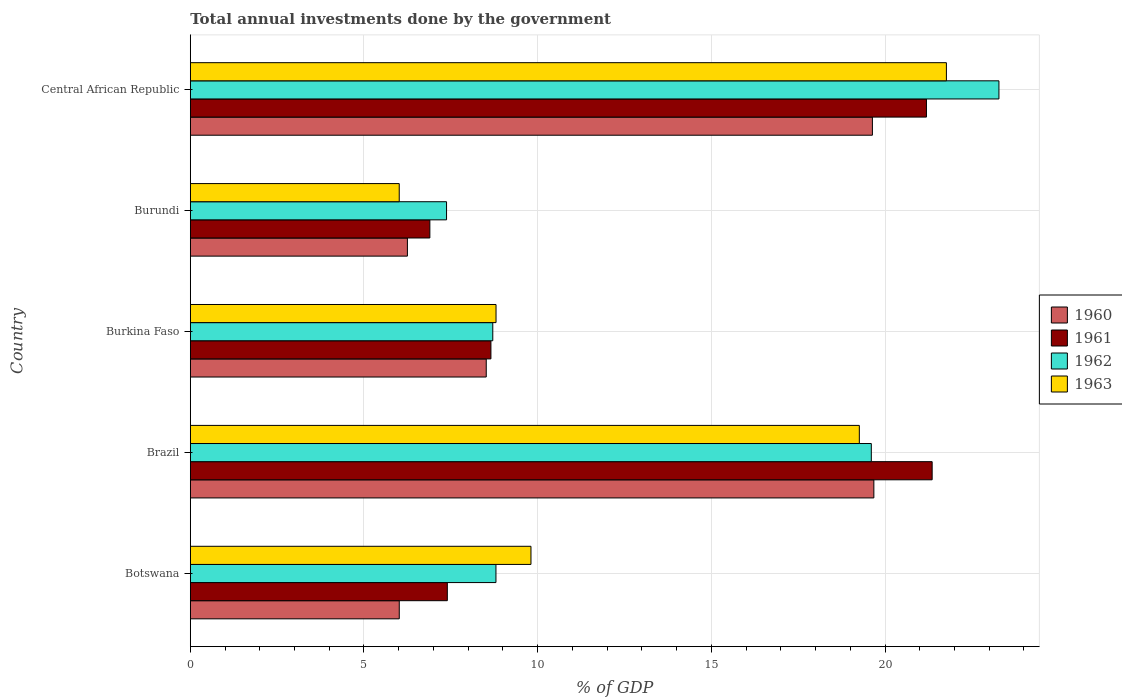How many different coloured bars are there?
Give a very brief answer. 4. How many groups of bars are there?
Your answer should be compact. 5. Are the number of bars per tick equal to the number of legend labels?
Provide a short and direct response. Yes. Are the number of bars on each tick of the Y-axis equal?
Give a very brief answer. Yes. How many bars are there on the 3rd tick from the top?
Provide a succinct answer. 4. How many bars are there on the 1st tick from the bottom?
Your answer should be compact. 4. What is the total annual investments done by the government in 1961 in Brazil?
Provide a short and direct response. 21.36. Across all countries, what is the maximum total annual investments done by the government in 1963?
Ensure brevity in your answer.  21.77. Across all countries, what is the minimum total annual investments done by the government in 1962?
Give a very brief answer. 7.38. In which country was the total annual investments done by the government in 1962 maximum?
Your answer should be very brief. Central African Republic. In which country was the total annual investments done by the government in 1962 minimum?
Your answer should be compact. Burundi. What is the total total annual investments done by the government in 1960 in the graph?
Give a very brief answer. 60.1. What is the difference between the total annual investments done by the government in 1960 in Botswana and that in Burundi?
Keep it short and to the point. -0.23. What is the difference between the total annual investments done by the government in 1960 in Burundi and the total annual investments done by the government in 1961 in Burkina Faso?
Your answer should be very brief. -2.4. What is the average total annual investments done by the government in 1962 per country?
Offer a terse response. 13.55. What is the difference between the total annual investments done by the government in 1961 and total annual investments done by the government in 1963 in Burkina Faso?
Offer a terse response. -0.15. In how many countries, is the total annual investments done by the government in 1960 greater than 1 %?
Your answer should be compact. 5. What is the ratio of the total annual investments done by the government in 1960 in Brazil to that in Central African Republic?
Give a very brief answer. 1. Is the difference between the total annual investments done by the government in 1961 in Botswana and Burundi greater than the difference between the total annual investments done by the government in 1963 in Botswana and Burundi?
Give a very brief answer. No. What is the difference between the highest and the second highest total annual investments done by the government in 1960?
Make the answer very short. 0.04. What is the difference between the highest and the lowest total annual investments done by the government in 1961?
Your answer should be compact. 14.46. In how many countries, is the total annual investments done by the government in 1960 greater than the average total annual investments done by the government in 1960 taken over all countries?
Keep it short and to the point. 2. Is the sum of the total annual investments done by the government in 1961 in Botswana and Brazil greater than the maximum total annual investments done by the government in 1962 across all countries?
Ensure brevity in your answer.  Yes. Is it the case that in every country, the sum of the total annual investments done by the government in 1963 and total annual investments done by the government in 1961 is greater than the sum of total annual investments done by the government in 1962 and total annual investments done by the government in 1960?
Your answer should be compact. No. How many bars are there?
Your answer should be very brief. 20. Are all the bars in the graph horizontal?
Make the answer very short. Yes. How many countries are there in the graph?
Your response must be concise. 5. What is the difference between two consecutive major ticks on the X-axis?
Make the answer very short. 5. Are the values on the major ticks of X-axis written in scientific E-notation?
Offer a terse response. No. How many legend labels are there?
Provide a succinct answer. 4. What is the title of the graph?
Your response must be concise. Total annual investments done by the government. What is the label or title of the X-axis?
Offer a terse response. % of GDP. What is the label or title of the Y-axis?
Your answer should be compact. Country. What is the % of GDP of 1960 in Botswana?
Your answer should be compact. 6.02. What is the % of GDP in 1961 in Botswana?
Ensure brevity in your answer.  7.4. What is the % of GDP of 1962 in Botswana?
Your answer should be compact. 8.8. What is the % of GDP of 1963 in Botswana?
Your answer should be very brief. 9.81. What is the % of GDP of 1960 in Brazil?
Provide a short and direct response. 19.68. What is the % of GDP in 1961 in Brazil?
Your response must be concise. 21.36. What is the % of GDP in 1962 in Brazil?
Keep it short and to the point. 19.6. What is the % of GDP in 1963 in Brazil?
Your answer should be compact. 19.26. What is the % of GDP in 1960 in Burkina Faso?
Your response must be concise. 8.52. What is the % of GDP in 1961 in Burkina Faso?
Your response must be concise. 8.65. What is the % of GDP of 1962 in Burkina Faso?
Ensure brevity in your answer.  8.71. What is the % of GDP of 1963 in Burkina Faso?
Ensure brevity in your answer.  8.8. What is the % of GDP in 1960 in Burundi?
Ensure brevity in your answer.  6.25. What is the % of GDP of 1961 in Burundi?
Give a very brief answer. 6.9. What is the % of GDP in 1962 in Burundi?
Keep it short and to the point. 7.38. What is the % of GDP in 1963 in Burundi?
Keep it short and to the point. 6.02. What is the % of GDP in 1960 in Central African Republic?
Offer a terse response. 19.64. What is the % of GDP in 1961 in Central African Republic?
Offer a terse response. 21.19. What is the % of GDP of 1962 in Central African Republic?
Your answer should be very brief. 23.28. What is the % of GDP of 1963 in Central African Republic?
Your answer should be compact. 21.77. Across all countries, what is the maximum % of GDP of 1960?
Your answer should be compact. 19.68. Across all countries, what is the maximum % of GDP of 1961?
Your response must be concise. 21.36. Across all countries, what is the maximum % of GDP in 1962?
Provide a succinct answer. 23.28. Across all countries, what is the maximum % of GDP in 1963?
Provide a succinct answer. 21.77. Across all countries, what is the minimum % of GDP of 1960?
Provide a succinct answer. 6.02. Across all countries, what is the minimum % of GDP in 1961?
Your answer should be very brief. 6.9. Across all countries, what is the minimum % of GDP in 1962?
Offer a very short reply. 7.38. Across all countries, what is the minimum % of GDP in 1963?
Your answer should be compact. 6.02. What is the total % of GDP in 1960 in the graph?
Give a very brief answer. 60.1. What is the total % of GDP in 1961 in the graph?
Keep it short and to the point. 65.5. What is the total % of GDP of 1962 in the graph?
Offer a very short reply. 67.77. What is the total % of GDP of 1963 in the graph?
Offer a terse response. 65.65. What is the difference between the % of GDP in 1960 in Botswana and that in Brazil?
Ensure brevity in your answer.  -13.66. What is the difference between the % of GDP of 1961 in Botswana and that in Brazil?
Ensure brevity in your answer.  -13.96. What is the difference between the % of GDP of 1962 in Botswana and that in Brazil?
Your answer should be very brief. -10.81. What is the difference between the % of GDP of 1963 in Botswana and that in Brazil?
Provide a short and direct response. -9.45. What is the difference between the % of GDP in 1960 in Botswana and that in Burkina Faso?
Give a very brief answer. -2.5. What is the difference between the % of GDP in 1961 in Botswana and that in Burkina Faso?
Provide a short and direct response. -1.25. What is the difference between the % of GDP of 1962 in Botswana and that in Burkina Faso?
Make the answer very short. 0.09. What is the difference between the % of GDP of 1963 in Botswana and that in Burkina Faso?
Provide a short and direct response. 1.01. What is the difference between the % of GDP in 1960 in Botswana and that in Burundi?
Your response must be concise. -0.23. What is the difference between the % of GDP of 1961 in Botswana and that in Burundi?
Offer a terse response. 0.5. What is the difference between the % of GDP of 1962 in Botswana and that in Burundi?
Give a very brief answer. 1.42. What is the difference between the % of GDP of 1963 in Botswana and that in Burundi?
Offer a terse response. 3.79. What is the difference between the % of GDP in 1960 in Botswana and that in Central African Republic?
Your answer should be compact. -13.62. What is the difference between the % of GDP of 1961 in Botswana and that in Central African Republic?
Your answer should be very brief. -13.79. What is the difference between the % of GDP of 1962 in Botswana and that in Central African Republic?
Give a very brief answer. -14.48. What is the difference between the % of GDP in 1963 in Botswana and that in Central African Republic?
Give a very brief answer. -11.96. What is the difference between the % of GDP in 1960 in Brazil and that in Burkina Faso?
Give a very brief answer. 11.16. What is the difference between the % of GDP in 1961 in Brazil and that in Burkina Faso?
Keep it short and to the point. 12.7. What is the difference between the % of GDP of 1962 in Brazil and that in Burkina Faso?
Provide a short and direct response. 10.9. What is the difference between the % of GDP of 1963 in Brazil and that in Burkina Faso?
Make the answer very short. 10.46. What is the difference between the % of GDP in 1960 in Brazil and that in Burundi?
Provide a short and direct response. 13.43. What is the difference between the % of GDP of 1961 in Brazil and that in Burundi?
Keep it short and to the point. 14.46. What is the difference between the % of GDP in 1962 in Brazil and that in Burundi?
Keep it short and to the point. 12.23. What is the difference between the % of GDP in 1963 in Brazil and that in Burundi?
Offer a very short reply. 13.24. What is the difference between the % of GDP in 1960 in Brazil and that in Central African Republic?
Provide a succinct answer. 0.04. What is the difference between the % of GDP of 1961 in Brazil and that in Central African Republic?
Offer a terse response. 0.16. What is the difference between the % of GDP in 1962 in Brazil and that in Central African Republic?
Provide a short and direct response. -3.67. What is the difference between the % of GDP in 1963 in Brazil and that in Central African Republic?
Offer a very short reply. -2.51. What is the difference between the % of GDP in 1960 in Burkina Faso and that in Burundi?
Your answer should be compact. 2.27. What is the difference between the % of GDP in 1961 in Burkina Faso and that in Burundi?
Ensure brevity in your answer.  1.76. What is the difference between the % of GDP in 1962 in Burkina Faso and that in Burundi?
Provide a succinct answer. 1.33. What is the difference between the % of GDP in 1963 in Burkina Faso and that in Burundi?
Your response must be concise. 2.79. What is the difference between the % of GDP in 1960 in Burkina Faso and that in Central African Republic?
Offer a very short reply. -11.12. What is the difference between the % of GDP in 1961 in Burkina Faso and that in Central African Republic?
Keep it short and to the point. -12.54. What is the difference between the % of GDP in 1962 in Burkina Faso and that in Central African Republic?
Make the answer very short. -14.57. What is the difference between the % of GDP of 1963 in Burkina Faso and that in Central African Republic?
Offer a very short reply. -12.97. What is the difference between the % of GDP in 1960 in Burundi and that in Central African Republic?
Your answer should be very brief. -13.39. What is the difference between the % of GDP in 1961 in Burundi and that in Central African Republic?
Make the answer very short. -14.3. What is the difference between the % of GDP in 1962 in Burundi and that in Central African Republic?
Give a very brief answer. -15.9. What is the difference between the % of GDP of 1963 in Burundi and that in Central African Republic?
Your response must be concise. -15.75. What is the difference between the % of GDP of 1960 in Botswana and the % of GDP of 1961 in Brazil?
Provide a short and direct response. -15.34. What is the difference between the % of GDP in 1960 in Botswana and the % of GDP in 1962 in Brazil?
Provide a succinct answer. -13.59. What is the difference between the % of GDP in 1960 in Botswana and the % of GDP in 1963 in Brazil?
Offer a very short reply. -13.24. What is the difference between the % of GDP of 1961 in Botswana and the % of GDP of 1962 in Brazil?
Give a very brief answer. -12.21. What is the difference between the % of GDP in 1961 in Botswana and the % of GDP in 1963 in Brazil?
Provide a succinct answer. -11.86. What is the difference between the % of GDP of 1962 in Botswana and the % of GDP of 1963 in Brazil?
Keep it short and to the point. -10.46. What is the difference between the % of GDP in 1960 in Botswana and the % of GDP in 1961 in Burkina Faso?
Your answer should be very brief. -2.64. What is the difference between the % of GDP of 1960 in Botswana and the % of GDP of 1962 in Burkina Faso?
Provide a short and direct response. -2.69. What is the difference between the % of GDP in 1960 in Botswana and the % of GDP in 1963 in Burkina Faso?
Ensure brevity in your answer.  -2.79. What is the difference between the % of GDP of 1961 in Botswana and the % of GDP of 1962 in Burkina Faso?
Your answer should be compact. -1.31. What is the difference between the % of GDP in 1961 in Botswana and the % of GDP in 1963 in Burkina Faso?
Your response must be concise. -1.4. What is the difference between the % of GDP in 1962 in Botswana and the % of GDP in 1963 in Burkina Faso?
Offer a terse response. -0. What is the difference between the % of GDP in 1960 in Botswana and the % of GDP in 1961 in Burundi?
Your answer should be compact. -0.88. What is the difference between the % of GDP in 1960 in Botswana and the % of GDP in 1962 in Burundi?
Provide a short and direct response. -1.36. What is the difference between the % of GDP in 1960 in Botswana and the % of GDP in 1963 in Burundi?
Offer a very short reply. 0. What is the difference between the % of GDP of 1961 in Botswana and the % of GDP of 1962 in Burundi?
Ensure brevity in your answer.  0.02. What is the difference between the % of GDP of 1961 in Botswana and the % of GDP of 1963 in Burundi?
Your response must be concise. 1.38. What is the difference between the % of GDP of 1962 in Botswana and the % of GDP of 1963 in Burundi?
Offer a very short reply. 2.78. What is the difference between the % of GDP in 1960 in Botswana and the % of GDP in 1961 in Central African Republic?
Keep it short and to the point. -15.18. What is the difference between the % of GDP of 1960 in Botswana and the % of GDP of 1962 in Central African Republic?
Your response must be concise. -17.26. What is the difference between the % of GDP in 1960 in Botswana and the % of GDP in 1963 in Central African Republic?
Offer a terse response. -15.75. What is the difference between the % of GDP of 1961 in Botswana and the % of GDP of 1962 in Central African Republic?
Provide a succinct answer. -15.88. What is the difference between the % of GDP of 1961 in Botswana and the % of GDP of 1963 in Central African Republic?
Your answer should be compact. -14.37. What is the difference between the % of GDP of 1962 in Botswana and the % of GDP of 1963 in Central African Republic?
Make the answer very short. -12.97. What is the difference between the % of GDP of 1960 in Brazil and the % of GDP of 1961 in Burkina Faso?
Make the answer very short. 11.02. What is the difference between the % of GDP in 1960 in Brazil and the % of GDP in 1962 in Burkina Faso?
Provide a short and direct response. 10.97. What is the difference between the % of GDP in 1960 in Brazil and the % of GDP in 1963 in Burkina Faso?
Your response must be concise. 10.88. What is the difference between the % of GDP of 1961 in Brazil and the % of GDP of 1962 in Burkina Faso?
Give a very brief answer. 12.65. What is the difference between the % of GDP in 1961 in Brazil and the % of GDP in 1963 in Burkina Faso?
Provide a succinct answer. 12.55. What is the difference between the % of GDP of 1962 in Brazil and the % of GDP of 1963 in Burkina Faso?
Your response must be concise. 10.8. What is the difference between the % of GDP of 1960 in Brazil and the % of GDP of 1961 in Burundi?
Ensure brevity in your answer.  12.78. What is the difference between the % of GDP in 1960 in Brazil and the % of GDP in 1962 in Burundi?
Keep it short and to the point. 12.3. What is the difference between the % of GDP in 1960 in Brazil and the % of GDP in 1963 in Burundi?
Offer a very short reply. 13.66. What is the difference between the % of GDP of 1961 in Brazil and the % of GDP of 1962 in Burundi?
Your response must be concise. 13.98. What is the difference between the % of GDP in 1961 in Brazil and the % of GDP in 1963 in Burundi?
Keep it short and to the point. 15.34. What is the difference between the % of GDP of 1962 in Brazil and the % of GDP of 1963 in Burundi?
Offer a very short reply. 13.59. What is the difference between the % of GDP of 1960 in Brazil and the % of GDP of 1961 in Central African Republic?
Give a very brief answer. -1.51. What is the difference between the % of GDP in 1960 in Brazil and the % of GDP in 1962 in Central African Republic?
Provide a short and direct response. -3.6. What is the difference between the % of GDP of 1960 in Brazil and the % of GDP of 1963 in Central African Republic?
Provide a succinct answer. -2.09. What is the difference between the % of GDP in 1961 in Brazil and the % of GDP in 1962 in Central African Republic?
Give a very brief answer. -1.92. What is the difference between the % of GDP of 1961 in Brazil and the % of GDP of 1963 in Central African Republic?
Ensure brevity in your answer.  -0.41. What is the difference between the % of GDP of 1962 in Brazil and the % of GDP of 1963 in Central African Republic?
Your response must be concise. -2.16. What is the difference between the % of GDP in 1960 in Burkina Faso and the % of GDP in 1961 in Burundi?
Your answer should be very brief. 1.62. What is the difference between the % of GDP in 1960 in Burkina Faso and the % of GDP in 1962 in Burundi?
Offer a terse response. 1.14. What is the difference between the % of GDP of 1960 in Burkina Faso and the % of GDP of 1963 in Burundi?
Offer a very short reply. 2.5. What is the difference between the % of GDP of 1961 in Burkina Faso and the % of GDP of 1962 in Burundi?
Provide a short and direct response. 1.28. What is the difference between the % of GDP in 1961 in Burkina Faso and the % of GDP in 1963 in Burundi?
Your answer should be very brief. 2.64. What is the difference between the % of GDP in 1962 in Burkina Faso and the % of GDP in 1963 in Burundi?
Provide a short and direct response. 2.69. What is the difference between the % of GDP in 1960 in Burkina Faso and the % of GDP in 1961 in Central African Republic?
Keep it short and to the point. -12.67. What is the difference between the % of GDP of 1960 in Burkina Faso and the % of GDP of 1962 in Central African Republic?
Make the answer very short. -14.76. What is the difference between the % of GDP in 1960 in Burkina Faso and the % of GDP in 1963 in Central African Republic?
Offer a terse response. -13.25. What is the difference between the % of GDP in 1961 in Burkina Faso and the % of GDP in 1962 in Central African Republic?
Your answer should be very brief. -14.62. What is the difference between the % of GDP of 1961 in Burkina Faso and the % of GDP of 1963 in Central African Republic?
Your answer should be compact. -13.11. What is the difference between the % of GDP in 1962 in Burkina Faso and the % of GDP in 1963 in Central African Republic?
Your answer should be compact. -13.06. What is the difference between the % of GDP in 1960 in Burundi and the % of GDP in 1961 in Central African Republic?
Your answer should be very brief. -14.94. What is the difference between the % of GDP of 1960 in Burundi and the % of GDP of 1962 in Central African Republic?
Ensure brevity in your answer.  -17.03. What is the difference between the % of GDP of 1960 in Burundi and the % of GDP of 1963 in Central African Republic?
Provide a succinct answer. -15.52. What is the difference between the % of GDP in 1961 in Burundi and the % of GDP in 1962 in Central African Republic?
Make the answer very short. -16.38. What is the difference between the % of GDP in 1961 in Burundi and the % of GDP in 1963 in Central African Republic?
Make the answer very short. -14.87. What is the difference between the % of GDP of 1962 in Burundi and the % of GDP of 1963 in Central African Republic?
Give a very brief answer. -14.39. What is the average % of GDP in 1960 per country?
Your response must be concise. 12.02. What is the average % of GDP of 1961 per country?
Your answer should be very brief. 13.1. What is the average % of GDP in 1962 per country?
Offer a very short reply. 13.55. What is the average % of GDP in 1963 per country?
Offer a very short reply. 13.13. What is the difference between the % of GDP in 1960 and % of GDP in 1961 in Botswana?
Provide a succinct answer. -1.38. What is the difference between the % of GDP in 1960 and % of GDP in 1962 in Botswana?
Ensure brevity in your answer.  -2.78. What is the difference between the % of GDP of 1960 and % of GDP of 1963 in Botswana?
Make the answer very short. -3.79. What is the difference between the % of GDP in 1961 and % of GDP in 1962 in Botswana?
Your answer should be compact. -1.4. What is the difference between the % of GDP in 1961 and % of GDP in 1963 in Botswana?
Keep it short and to the point. -2.41. What is the difference between the % of GDP in 1962 and % of GDP in 1963 in Botswana?
Your answer should be compact. -1.01. What is the difference between the % of GDP of 1960 and % of GDP of 1961 in Brazil?
Your answer should be compact. -1.68. What is the difference between the % of GDP in 1960 and % of GDP in 1962 in Brazil?
Ensure brevity in your answer.  0.07. What is the difference between the % of GDP in 1960 and % of GDP in 1963 in Brazil?
Keep it short and to the point. 0.42. What is the difference between the % of GDP in 1961 and % of GDP in 1962 in Brazil?
Offer a very short reply. 1.75. What is the difference between the % of GDP in 1961 and % of GDP in 1963 in Brazil?
Your answer should be compact. 2.1. What is the difference between the % of GDP in 1962 and % of GDP in 1963 in Brazil?
Keep it short and to the point. 0.34. What is the difference between the % of GDP in 1960 and % of GDP in 1961 in Burkina Faso?
Ensure brevity in your answer.  -0.13. What is the difference between the % of GDP of 1960 and % of GDP of 1962 in Burkina Faso?
Ensure brevity in your answer.  -0.19. What is the difference between the % of GDP in 1960 and % of GDP in 1963 in Burkina Faso?
Your response must be concise. -0.28. What is the difference between the % of GDP in 1961 and % of GDP in 1962 in Burkina Faso?
Keep it short and to the point. -0.05. What is the difference between the % of GDP in 1961 and % of GDP in 1963 in Burkina Faso?
Offer a terse response. -0.15. What is the difference between the % of GDP of 1962 and % of GDP of 1963 in Burkina Faso?
Your response must be concise. -0.09. What is the difference between the % of GDP in 1960 and % of GDP in 1961 in Burundi?
Ensure brevity in your answer.  -0.65. What is the difference between the % of GDP in 1960 and % of GDP in 1962 in Burundi?
Offer a very short reply. -1.13. What is the difference between the % of GDP of 1960 and % of GDP of 1963 in Burundi?
Keep it short and to the point. 0.23. What is the difference between the % of GDP in 1961 and % of GDP in 1962 in Burundi?
Ensure brevity in your answer.  -0.48. What is the difference between the % of GDP of 1961 and % of GDP of 1963 in Burundi?
Keep it short and to the point. 0.88. What is the difference between the % of GDP of 1962 and % of GDP of 1963 in Burundi?
Keep it short and to the point. 1.36. What is the difference between the % of GDP of 1960 and % of GDP of 1961 in Central African Republic?
Your response must be concise. -1.56. What is the difference between the % of GDP in 1960 and % of GDP in 1962 in Central African Republic?
Your response must be concise. -3.64. What is the difference between the % of GDP of 1960 and % of GDP of 1963 in Central African Republic?
Your answer should be very brief. -2.13. What is the difference between the % of GDP of 1961 and % of GDP of 1962 in Central African Republic?
Your response must be concise. -2.09. What is the difference between the % of GDP in 1961 and % of GDP in 1963 in Central African Republic?
Your answer should be very brief. -0.57. What is the difference between the % of GDP in 1962 and % of GDP in 1963 in Central African Republic?
Keep it short and to the point. 1.51. What is the ratio of the % of GDP in 1960 in Botswana to that in Brazil?
Provide a succinct answer. 0.31. What is the ratio of the % of GDP of 1961 in Botswana to that in Brazil?
Give a very brief answer. 0.35. What is the ratio of the % of GDP in 1962 in Botswana to that in Brazil?
Provide a succinct answer. 0.45. What is the ratio of the % of GDP of 1963 in Botswana to that in Brazil?
Ensure brevity in your answer.  0.51. What is the ratio of the % of GDP of 1960 in Botswana to that in Burkina Faso?
Give a very brief answer. 0.71. What is the ratio of the % of GDP of 1961 in Botswana to that in Burkina Faso?
Keep it short and to the point. 0.85. What is the ratio of the % of GDP in 1962 in Botswana to that in Burkina Faso?
Provide a short and direct response. 1.01. What is the ratio of the % of GDP of 1963 in Botswana to that in Burkina Faso?
Ensure brevity in your answer.  1.11. What is the ratio of the % of GDP in 1960 in Botswana to that in Burundi?
Your answer should be compact. 0.96. What is the ratio of the % of GDP of 1961 in Botswana to that in Burundi?
Make the answer very short. 1.07. What is the ratio of the % of GDP of 1962 in Botswana to that in Burundi?
Provide a succinct answer. 1.19. What is the ratio of the % of GDP in 1963 in Botswana to that in Burundi?
Offer a terse response. 1.63. What is the ratio of the % of GDP in 1960 in Botswana to that in Central African Republic?
Your answer should be compact. 0.31. What is the ratio of the % of GDP of 1961 in Botswana to that in Central African Republic?
Provide a short and direct response. 0.35. What is the ratio of the % of GDP in 1962 in Botswana to that in Central African Republic?
Your answer should be compact. 0.38. What is the ratio of the % of GDP of 1963 in Botswana to that in Central African Republic?
Your response must be concise. 0.45. What is the ratio of the % of GDP of 1960 in Brazil to that in Burkina Faso?
Keep it short and to the point. 2.31. What is the ratio of the % of GDP in 1961 in Brazil to that in Burkina Faso?
Offer a very short reply. 2.47. What is the ratio of the % of GDP in 1962 in Brazil to that in Burkina Faso?
Offer a terse response. 2.25. What is the ratio of the % of GDP in 1963 in Brazil to that in Burkina Faso?
Give a very brief answer. 2.19. What is the ratio of the % of GDP of 1960 in Brazil to that in Burundi?
Give a very brief answer. 3.15. What is the ratio of the % of GDP of 1961 in Brazil to that in Burundi?
Offer a very short reply. 3.1. What is the ratio of the % of GDP of 1962 in Brazil to that in Burundi?
Make the answer very short. 2.66. What is the ratio of the % of GDP of 1963 in Brazil to that in Burundi?
Your answer should be compact. 3.2. What is the ratio of the % of GDP in 1961 in Brazil to that in Central African Republic?
Ensure brevity in your answer.  1.01. What is the ratio of the % of GDP in 1962 in Brazil to that in Central African Republic?
Keep it short and to the point. 0.84. What is the ratio of the % of GDP of 1963 in Brazil to that in Central African Republic?
Provide a succinct answer. 0.88. What is the ratio of the % of GDP of 1960 in Burkina Faso to that in Burundi?
Provide a short and direct response. 1.36. What is the ratio of the % of GDP in 1961 in Burkina Faso to that in Burundi?
Provide a succinct answer. 1.25. What is the ratio of the % of GDP in 1962 in Burkina Faso to that in Burundi?
Offer a terse response. 1.18. What is the ratio of the % of GDP in 1963 in Burkina Faso to that in Burundi?
Your answer should be compact. 1.46. What is the ratio of the % of GDP in 1960 in Burkina Faso to that in Central African Republic?
Make the answer very short. 0.43. What is the ratio of the % of GDP of 1961 in Burkina Faso to that in Central African Republic?
Keep it short and to the point. 0.41. What is the ratio of the % of GDP in 1962 in Burkina Faso to that in Central African Republic?
Provide a short and direct response. 0.37. What is the ratio of the % of GDP in 1963 in Burkina Faso to that in Central African Republic?
Offer a terse response. 0.4. What is the ratio of the % of GDP of 1960 in Burundi to that in Central African Republic?
Offer a very short reply. 0.32. What is the ratio of the % of GDP in 1961 in Burundi to that in Central African Republic?
Your answer should be compact. 0.33. What is the ratio of the % of GDP in 1962 in Burundi to that in Central African Republic?
Ensure brevity in your answer.  0.32. What is the ratio of the % of GDP in 1963 in Burundi to that in Central African Republic?
Provide a short and direct response. 0.28. What is the difference between the highest and the second highest % of GDP of 1960?
Offer a very short reply. 0.04. What is the difference between the highest and the second highest % of GDP in 1961?
Keep it short and to the point. 0.16. What is the difference between the highest and the second highest % of GDP in 1962?
Make the answer very short. 3.67. What is the difference between the highest and the second highest % of GDP in 1963?
Ensure brevity in your answer.  2.51. What is the difference between the highest and the lowest % of GDP of 1960?
Ensure brevity in your answer.  13.66. What is the difference between the highest and the lowest % of GDP in 1961?
Your response must be concise. 14.46. What is the difference between the highest and the lowest % of GDP in 1962?
Ensure brevity in your answer.  15.9. What is the difference between the highest and the lowest % of GDP in 1963?
Ensure brevity in your answer.  15.75. 